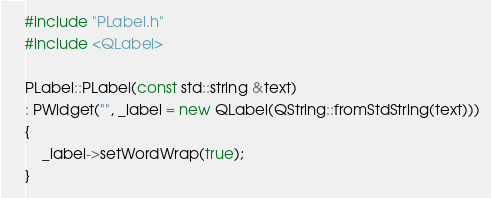Convert code to text. <code><loc_0><loc_0><loc_500><loc_500><_C++_>#include "PLabel.h"
#include <QLabel>

PLabel::PLabel(const std::string &text)
: PWidget("", _label = new QLabel(QString::fromStdString(text)))
{
    _label->setWordWrap(true);
}
</code> 